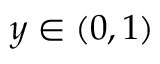Convert formula to latex. <formula><loc_0><loc_0><loc_500><loc_500>y \in ( 0 , 1 )</formula> 